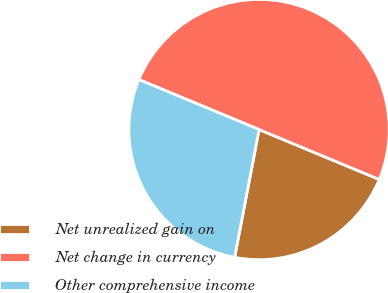<chart> <loc_0><loc_0><loc_500><loc_500><pie_chart><fcel>Net unrealized gain on<fcel>Net change in currency<fcel>Other comprehensive income<nl><fcel>21.74%<fcel>50.0%<fcel>28.26%<nl></chart> 